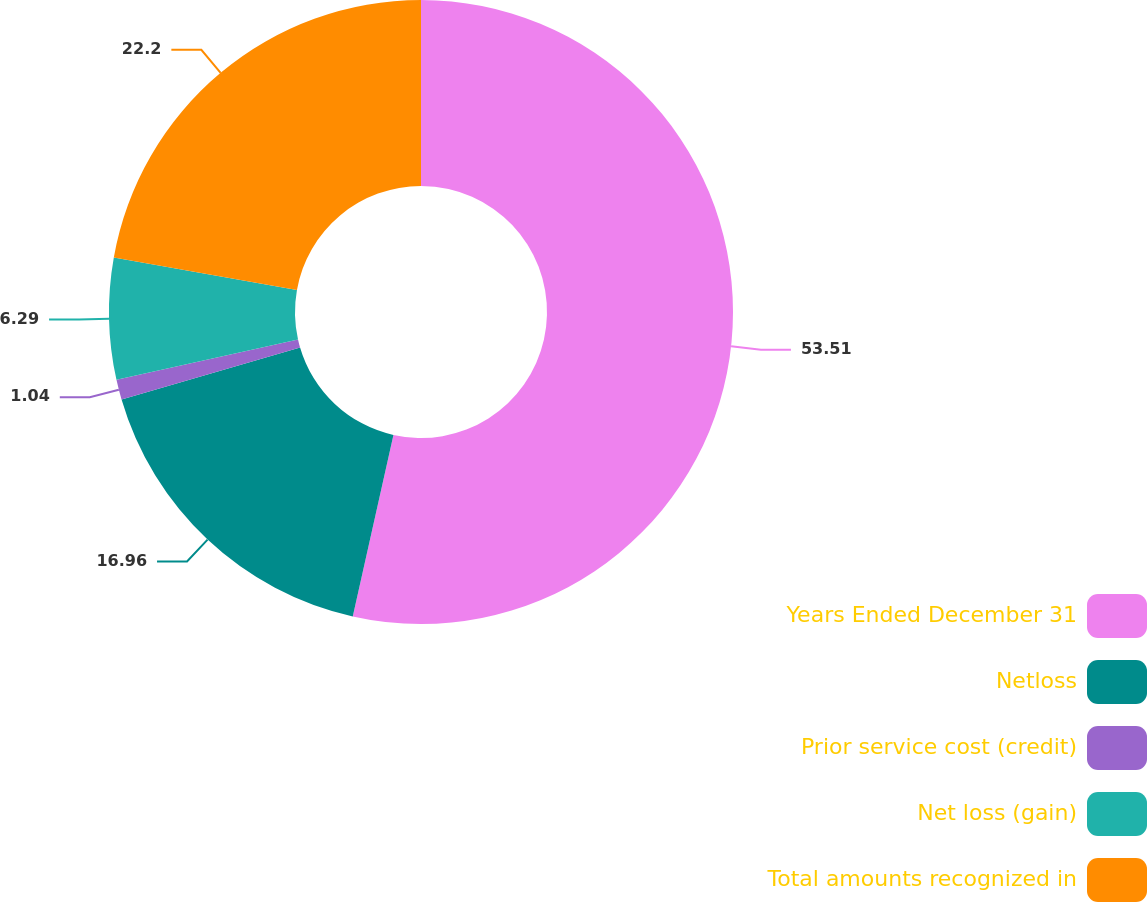Convert chart to OTSL. <chart><loc_0><loc_0><loc_500><loc_500><pie_chart><fcel>Years Ended December 31<fcel>Netloss<fcel>Prior service cost (credit)<fcel>Net loss (gain)<fcel>Total amounts recognized in<nl><fcel>53.51%<fcel>16.96%<fcel>1.04%<fcel>6.29%<fcel>22.2%<nl></chart> 